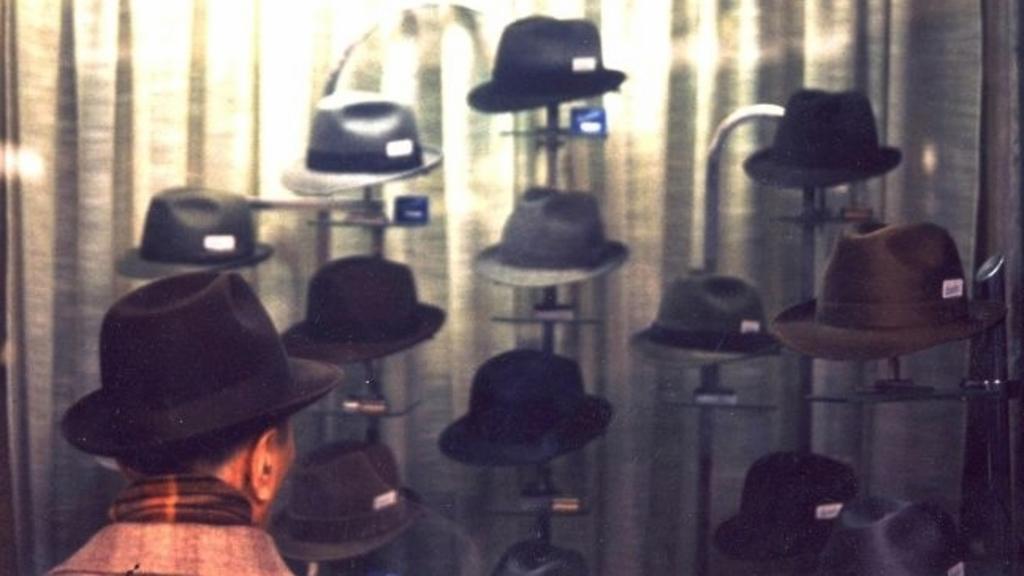In one or two sentences, can you explain what this image depicts? This man wore a hat. Background there are hats. 